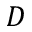Convert formula to latex. <formula><loc_0><loc_0><loc_500><loc_500>D</formula> 